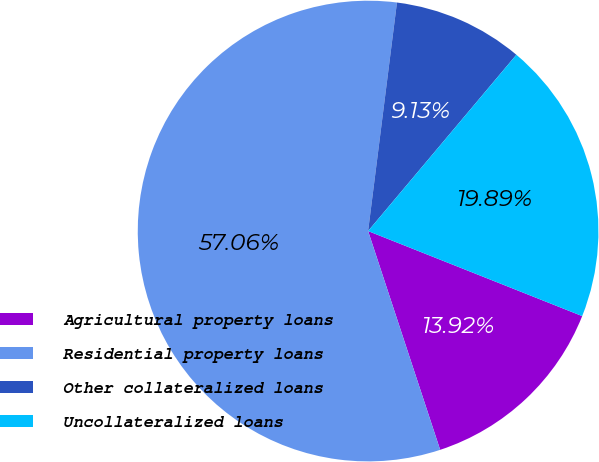Convert chart. <chart><loc_0><loc_0><loc_500><loc_500><pie_chart><fcel>Agricultural property loans<fcel>Residential property loans<fcel>Other collateralized loans<fcel>Uncollateralized loans<nl><fcel>13.92%<fcel>57.07%<fcel>9.13%<fcel>19.89%<nl></chart> 